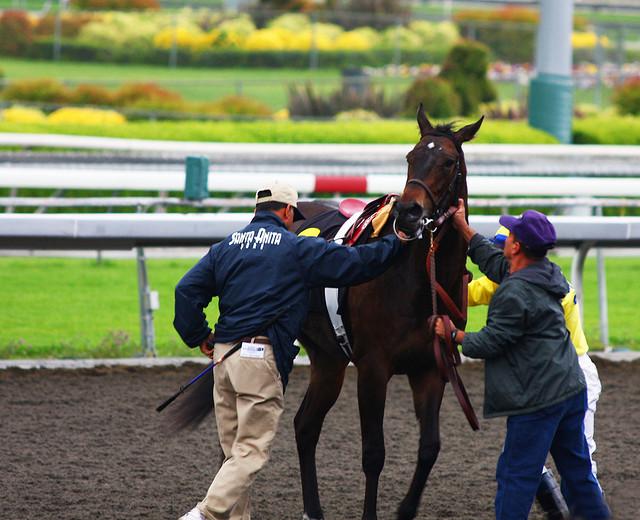Is the rider telling the horse to run faster?
Quick response, please. No. How many men are in this photo?
Keep it brief. 2. Does the man's jacket say Santa Anita?
Short answer required. Yes. Was the photo taken at Santa Anita racetrack?
Write a very short answer. Yes. 